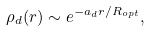<formula> <loc_0><loc_0><loc_500><loc_500>\rho _ { d } ( r ) \sim e ^ { - a _ { d } r / R _ { o p t } } ,</formula> 